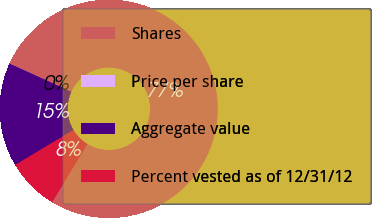Convert chart. <chart><loc_0><loc_0><loc_500><loc_500><pie_chart><fcel>Shares<fcel>Price per share<fcel>Aggregate value<fcel>Percent vested as of 12/31/12<nl><fcel>76.88%<fcel>0.02%<fcel>15.39%<fcel>7.71%<nl></chart> 